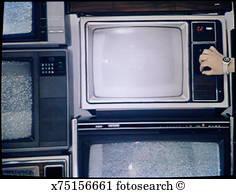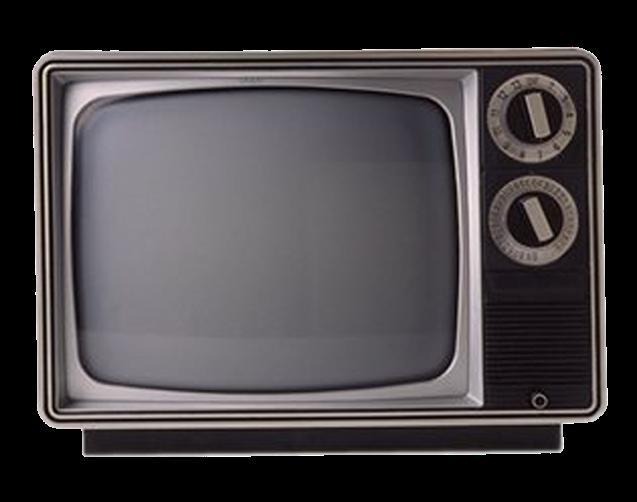The first image is the image on the left, the second image is the image on the right. For the images shown, is this caption "There is exactly one television in the right image and multiple televisions in the left image." true? Answer yes or no. Yes. The first image is the image on the left, the second image is the image on the right. Given the left and right images, does the statement "the right image contains 1 tv" hold true? Answer yes or no. Yes. 